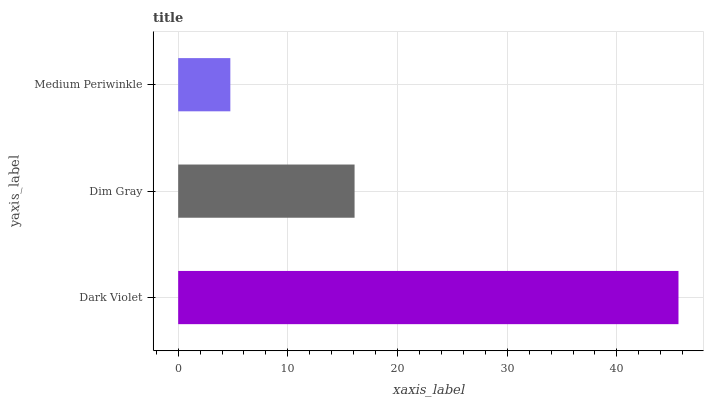Is Medium Periwinkle the minimum?
Answer yes or no. Yes. Is Dark Violet the maximum?
Answer yes or no. Yes. Is Dim Gray the minimum?
Answer yes or no. No. Is Dim Gray the maximum?
Answer yes or no. No. Is Dark Violet greater than Dim Gray?
Answer yes or no. Yes. Is Dim Gray less than Dark Violet?
Answer yes or no. Yes. Is Dim Gray greater than Dark Violet?
Answer yes or no. No. Is Dark Violet less than Dim Gray?
Answer yes or no. No. Is Dim Gray the high median?
Answer yes or no. Yes. Is Dim Gray the low median?
Answer yes or no. Yes. Is Dark Violet the high median?
Answer yes or no. No. Is Dark Violet the low median?
Answer yes or no. No. 